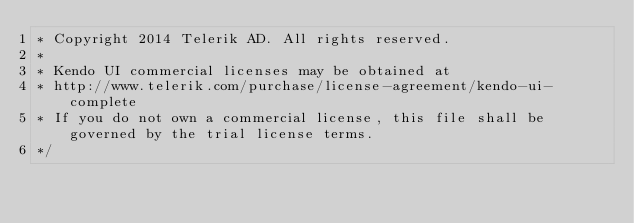<code> <loc_0><loc_0><loc_500><loc_500><_CSS_>* Copyright 2014 Telerik AD. All rights reserved.
*
* Kendo UI commercial licenses may be obtained at
* http://www.telerik.com/purchase/license-agreement/kendo-ui-complete
* If you do not own a commercial license, this file shall be governed by the trial license terms.
*/</code> 